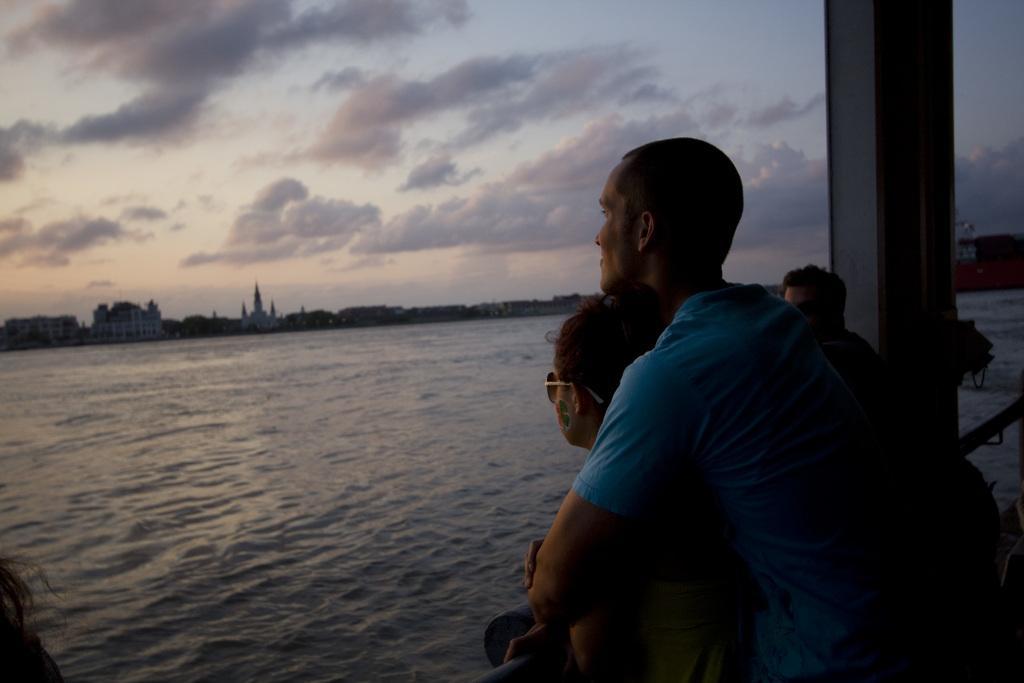Can you describe this image briefly? In the foreground of this image, on the right, there are people standing and there is a pillar. In the background, there is water, sky and the cloud. 